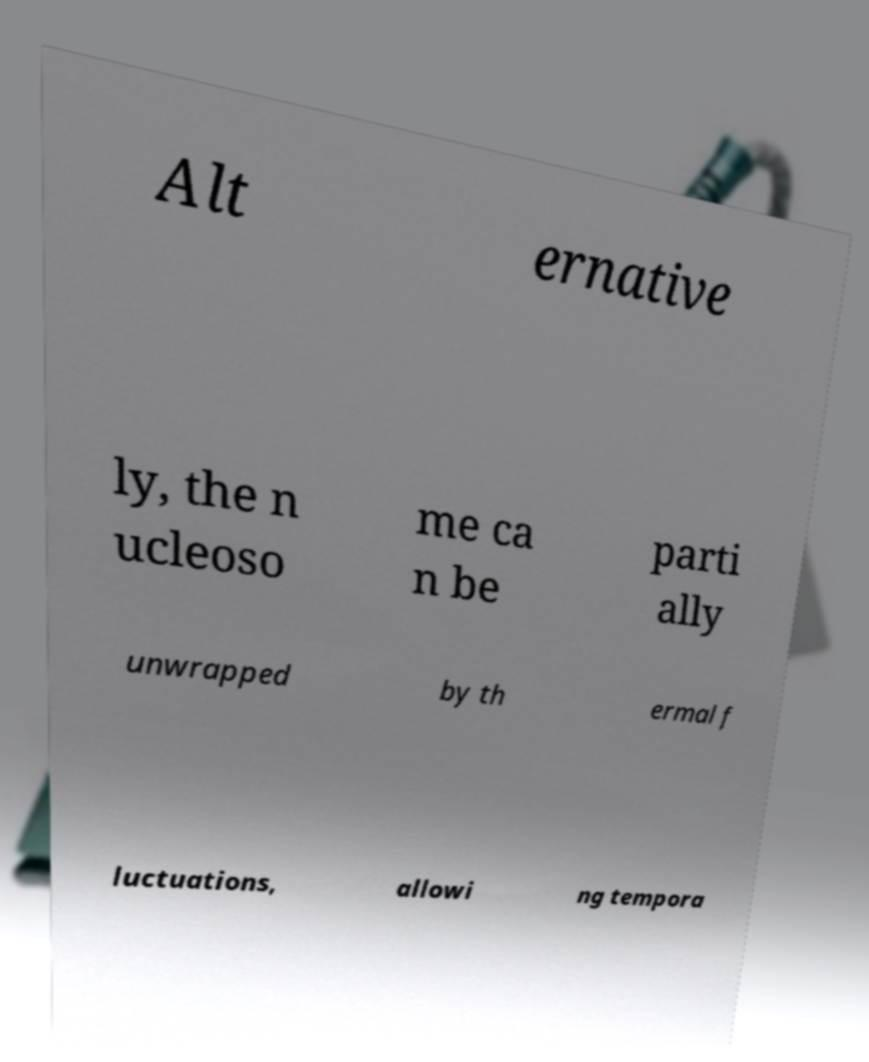What messages or text are displayed in this image? I need them in a readable, typed format. Alt ernative ly, the n ucleoso me ca n be parti ally unwrapped by th ermal f luctuations, allowi ng tempora 